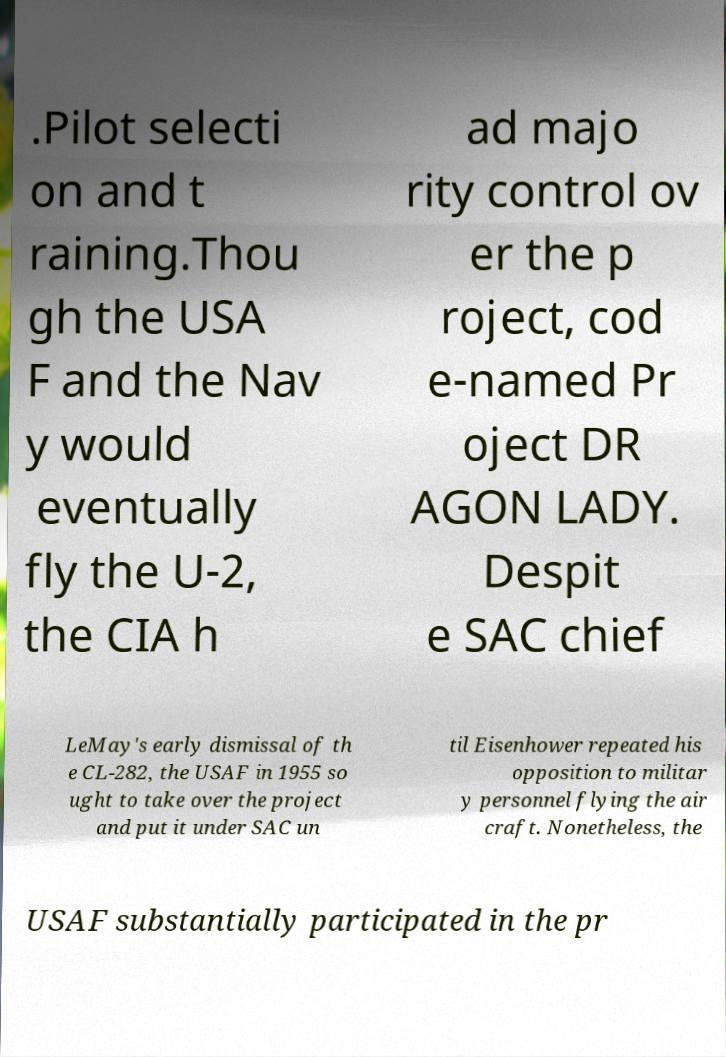Can you read and provide the text displayed in the image?This photo seems to have some interesting text. Can you extract and type it out for me? .Pilot selecti on and t raining.Thou gh the USA F and the Nav y would eventually fly the U-2, the CIA h ad majo rity control ov er the p roject, cod e-named Pr oject DR AGON LADY. Despit e SAC chief LeMay's early dismissal of th e CL-282, the USAF in 1955 so ught to take over the project and put it under SAC un til Eisenhower repeated his opposition to militar y personnel flying the air craft. Nonetheless, the USAF substantially participated in the pr 